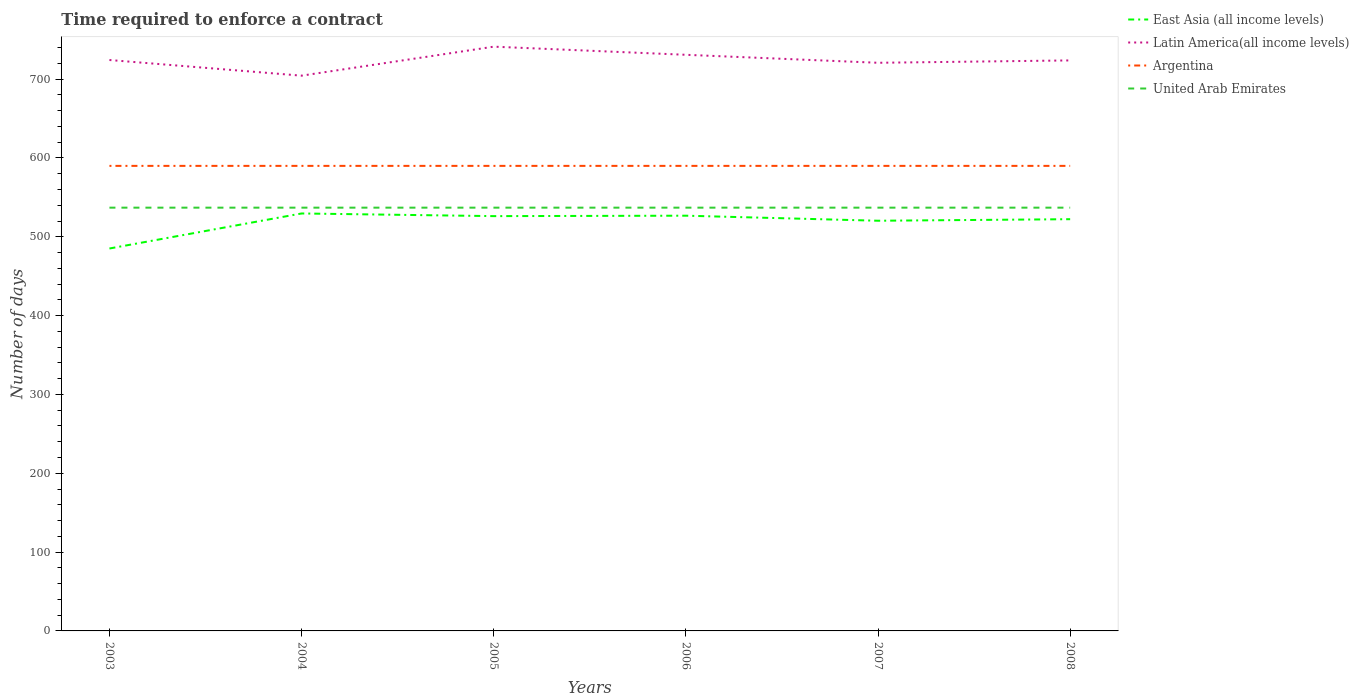Does the line corresponding to Argentina intersect with the line corresponding to East Asia (all income levels)?
Provide a short and direct response. No. Is the number of lines equal to the number of legend labels?
Make the answer very short. Yes. Across all years, what is the maximum number of days required to enforce a contract in Latin America(all income levels)?
Ensure brevity in your answer.  704.45. What is the total number of days required to enforce a contract in United Arab Emirates in the graph?
Give a very brief answer. 0. What is the difference between the highest and the second highest number of days required to enforce a contract in Latin America(all income levels)?
Make the answer very short. 36.79. What is the difference between the highest and the lowest number of days required to enforce a contract in United Arab Emirates?
Your response must be concise. 0. Is the number of days required to enforce a contract in East Asia (all income levels) strictly greater than the number of days required to enforce a contract in Argentina over the years?
Provide a succinct answer. Yes. What is the difference between two consecutive major ticks on the Y-axis?
Your answer should be very brief. 100. Are the values on the major ticks of Y-axis written in scientific E-notation?
Offer a terse response. No. Where does the legend appear in the graph?
Your answer should be compact. Top right. How are the legend labels stacked?
Provide a short and direct response. Vertical. What is the title of the graph?
Keep it short and to the point. Time required to enforce a contract. Does "Denmark" appear as one of the legend labels in the graph?
Offer a very short reply. No. What is the label or title of the X-axis?
Give a very brief answer. Years. What is the label or title of the Y-axis?
Offer a very short reply. Number of days. What is the Number of days of East Asia (all income levels) in 2003?
Give a very brief answer. 485.17. What is the Number of days in Latin America(all income levels) in 2003?
Ensure brevity in your answer.  724.32. What is the Number of days of Argentina in 2003?
Your answer should be very brief. 590. What is the Number of days of United Arab Emirates in 2003?
Offer a very short reply. 537. What is the Number of days in East Asia (all income levels) in 2004?
Ensure brevity in your answer.  529.62. What is the Number of days in Latin America(all income levels) in 2004?
Your answer should be compact. 704.45. What is the Number of days in Argentina in 2004?
Your answer should be very brief. 590. What is the Number of days in United Arab Emirates in 2004?
Provide a succinct answer. 537. What is the Number of days of East Asia (all income levels) in 2005?
Give a very brief answer. 526.25. What is the Number of days of Latin America(all income levels) in 2005?
Your answer should be very brief. 741.24. What is the Number of days in Argentina in 2005?
Make the answer very short. 590. What is the Number of days of United Arab Emirates in 2005?
Give a very brief answer. 537. What is the Number of days of East Asia (all income levels) in 2006?
Ensure brevity in your answer.  526.8. What is the Number of days of Latin America(all income levels) in 2006?
Your response must be concise. 730.93. What is the Number of days of Argentina in 2006?
Offer a very short reply. 590. What is the Number of days of United Arab Emirates in 2006?
Your response must be concise. 537. What is the Number of days of East Asia (all income levels) in 2007?
Your answer should be compact. 520.4. What is the Number of days in Latin America(all income levels) in 2007?
Give a very brief answer. 720.8. What is the Number of days in Argentina in 2007?
Keep it short and to the point. 590. What is the Number of days of United Arab Emirates in 2007?
Your response must be concise. 537. What is the Number of days of East Asia (all income levels) in 2008?
Keep it short and to the point. 522.36. What is the Number of days in Latin America(all income levels) in 2008?
Ensure brevity in your answer.  723.8. What is the Number of days of Argentina in 2008?
Make the answer very short. 590. What is the Number of days in United Arab Emirates in 2008?
Your answer should be compact. 537. Across all years, what is the maximum Number of days of East Asia (all income levels)?
Provide a short and direct response. 529.62. Across all years, what is the maximum Number of days of Latin America(all income levels)?
Make the answer very short. 741.24. Across all years, what is the maximum Number of days in Argentina?
Offer a terse response. 590. Across all years, what is the maximum Number of days of United Arab Emirates?
Offer a very short reply. 537. Across all years, what is the minimum Number of days of East Asia (all income levels)?
Your answer should be very brief. 485.17. Across all years, what is the minimum Number of days in Latin America(all income levels)?
Provide a succinct answer. 704.45. Across all years, what is the minimum Number of days of Argentina?
Make the answer very short. 590. Across all years, what is the minimum Number of days in United Arab Emirates?
Your response must be concise. 537. What is the total Number of days in East Asia (all income levels) in the graph?
Give a very brief answer. 3110.61. What is the total Number of days of Latin America(all income levels) in the graph?
Provide a short and direct response. 4345.54. What is the total Number of days of Argentina in the graph?
Offer a very short reply. 3540. What is the total Number of days in United Arab Emirates in the graph?
Your answer should be very brief. 3222. What is the difference between the Number of days of East Asia (all income levels) in 2003 and that in 2004?
Offer a terse response. -44.45. What is the difference between the Number of days of Latin America(all income levels) in 2003 and that in 2004?
Your answer should be compact. 19.87. What is the difference between the Number of days of Argentina in 2003 and that in 2004?
Your answer should be very brief. 0. What is the difference between the Number of days of East Asia (all income levels) in 2003 and that in 2005?
Your response must be concise. -41.08. What is the difference between the Number of days of Latin America(all income levels) in 2003 and that in 2005?
Offer a terse response. -16.93. What is the difference between the Number of days in Argentina in 2003 and that in 2005?
Offer a very short reply. 0. What is the difference between the Number of days in United Arab Emirates in 2003 and that in 2005?
Make the answer very short. 0. What is the difference between the Number of days in East Asia (all income levels) in 2003 and that in 2006?
Provide a short and direct response. -41.63. What is the difference between the Number of days of Latin America(all income levels) in 2003 and that in 2006?
Keep it short and to the point. -6.62. What is the difference between the Number of days in East Asia (all income levels) in 2003 and that in 2007?
Your answer should be very brief. -35.23. What is the difference between the Number of days of Latin America(all income levels) in 2003 and that in 2007?
Your answer should be very brief. 3.52. What is the difference between the Number of days in East Asia (all income levels) in 2003 and that in 2008?
Keep it short and to the point. -37.19. What is the difference between the Number of days in Latin America(all income levels) in 2003 and that in 2008?
Your answer should be very brief. 0.52. What is the difference between the Number of days of United Arab Emirates in 2003 and that in 2008?
Keep it short and to the point. 0. What is the difference between the Number of days of East Asia (all income levels) in 2004 and that in 2005?
Provide a succinct answer. 3.38. What is the difference between the Number of days in Latin America(all income levels) in 2004 and that in 2005?
Offer a terse response. -36.79. What is the difference between the Number of days of United Arab Emirates in 2004 and that in 2005?
Ensure brevity in your answer.  0. What is the difference between the Number of days of East Asia (all income levels) in 2004 and that in 2006?
Provide a succinct answer. 2.83. What is the difference between the Number of days in Latin America(all income levels) in 2004 and that in 2006?
Offer a terse response. -26.48. What is the difference between the Number of days in Argentina in 2004 and that in 2006?
Give a very brief answer. 0. What is the difference between the Number of days of United Arab Emirates in 2004 and that in 2006?
Keep it short and to the point. 0. What is the difference between the Number of days in East Asia (all income levels) in 2004 and that in 2007?
Provide a succinct answer. 9.22. What is the difference between the Number of days of Latin America(all income levels) in 2004 and that in 2007?
Offer a very short reply. -16.35. What is the difference between the Number of days of Argentina in 2004 and that in 2007?
Offer a very short reply. 0. What is the difference between the Number of days in United Arab Emirates in 2004 and that in 2007?
Your response must be concise. 0. What is the difference between the Number of days in East Asia (all income levels) in 2004 and that in 2008?
Give a very brief answer. 7.26. What is the difference between the Number of days of Latin America(all income levels) in 2004 and that in 2008?
Offer a terse response. -19.35. What is the difference between the Number of days in Argentina in 2004 and that in 2008?
Offer a very short reply. 0. What is the difference between the Number of days of East Asia (all income levels) in 2005 and that in 2006?
Your response must be concise. -0.55. What is the difference between the Number of days in Latin America(all income levels) in 2005 and that in 2006?
Your response must be concise. 10.31. What is the difference between the Number of days in United Arab Emirates in 2005 and that in 2006?
Provide a succinct answer. 0. What is the difference between the Number of days in East Asia (all income levels) in 2005 and that in 2007?
Offer a very short reply. 5.85. What is the difference between the Number of days of Latin America(all income levels) in 2005 and that in 2007?
Your response must be concise. 20.44. What is the difference between the Number of days in Argentina in 2005 and that in 2007?
Provide a succinct answer. 0. What is the difference between the Number of days of East Asia (all income levels) in 2005 and that in 2008?
Make the answer very short. 3.89. What is the difference between the Number of days of Latin America(all income levels) in 2005 and that in 2008?
Offer a very short reply. 17.44. What is the difference between the Number of days in Argentina in 2005 and that in 2008?
Make the answer very short. 0. What is the difference between the Number of days in Latin America(all income levels) in 2006 and that in 2007?
Provide a succinct answer. 10.13. What is the difference between the Number of days in Argentina in 2006 and that in 2007?
Your answer should be very brief. 0. What is the difference between the Number of days in United Arab Emirates in 2006 and that in 2007?
Make the answer very short. 0. What is the difference between the Number of days of East Asia (all income levels) in 2006 and that in 2008?
Offer a terse response. 4.44. What is the difference between the Number of days in Latin America(all income levels) in 2006 and that in 2008?
Provide a short and direct response. 7.13. What is the difference between the Number of days in United Arab Emirates in 2006 and that in 2008?
Offer a terse response. 0. What is the difference between the Number of days of East Asia (all income levels) in 2007 and that in 2008?
Keep it short and to the point. -1.96. What is the difference between the Number of days in Latin America(all income levels) in 2007 and that in 2008?
Offer a terse response. -3. What is the difference between the Number of days in United Arab Emirates in 2007 and that in 2008?
Provide a succinct answer. 0. What is the difference between the Number of days in East Asia (all income levels) in 2003 and the Number of days in Latin America(all income levels) in 2004?
Offer a very short reply. -219.28. What is the difference between the Number of days of East Asia (all income levels) in 2003 and the Number of days of Argentina in 2004?
Make the answer very short. -104.83. What is the difference between the Number of days of East Asia (all income levels) in 2003 and the Number of days of United Arab Emirates in 2004?
Your answer should be compact. -51.83. What is the difference between the Number of days of Latin America(all income levels) in 2003 and the Number of days of Argentina in 2004?
Provide a succinct answer. 134.32. What is the difference between the Number of days in Latin America(all income levels) in 2003 and the Number of days in United Arab Emirates in 2004?
Ensure brevity in your answer.  187.32. What is the difference between the Number of days in East Asia (all income levels) in 2003 and the Number of days in Latin America(all income levels) in 2005?
Ensure brevity in your answer.  -256.07. What is the difference between the Number of days of East Asia (all income levels) in 2003 and the Number of days of Argentina in 2005?
Your answer should be compact. -104.83. What is the difference between the Number of days of East Asia (all income levels) in 2003 and the Number of days of United Arab Emirates in 2005?
Your response must be concise. -51.83. What is the difference between the Number of days in Latin America(all income levels) in 2003 and the Number of days in Argentina in 2005?
Make the answer very short. 134.32. What is the difference between the Number of days in Latin America(all income levels) in 2003 and the Number of days in United Arab Emirates in 2005?
Provide a succinct answer. 187.32. What is the difference between the Number of days of East Asia (all income levels) in 2003 and the Number of days of Latin America(all income levels) in 2006?
Your answer should be very brief. -245.76. What is the difference between the Number of days in East Asia (all income levels) in 2003 and the Number of days in Argentina in 2006?
Provide a short and direct response. -104.83. What is the difference between the Number of days in East Asia (all income levels) in 2003 and the Number of days in United Arab Emirates in 2006?
Give a very brief answer. -51.83. What is the difference between the Number of days in Latin America(all income levels) in 2003 and the Number of days in Argentina in 2006?
Provide a succinct answer. 134.32. What is the difference between the Number of days in Latin America(all income levels) in 2003 and the Number of days in United Arab Emirates in 2006?
Provide a short and direct response. 187.32. What is the difference between the Number of days of East Asia (all income levels) in 2003 and the Number of days of Latin America(all income levels) in 2007?
Your answer should be compact. -235.63. What is the difference between the Number of days of East Asia (all income levels) in 2003 and the Number of days of Argentina in 2007?
Make the answer very short. -104.83. What is the difference between the Number of days in East Asia (all income levels) in 2003 and the Number of days in United Arab Emirates in 2007?
Provide a short and direct response. -51.83. What is the difference between the Number of days in Latin America(all income levels) in 2003 and the Number of days in Argentina in 2007?
Offer a very short reply. 134.32. What is the difference between the Number of days in Latin America(all income levels) in 2003 and the Number of days in United Arab Emirates in 2007?
Your response must be concise. 187.32. What is the difference between the Number of days of East Asia (all income levels) in 2003 and the Number of days of Latin America(all income levels) in 2008?
Make the answer very short. -238.63. What is the difference between the Number of days in East Asia (all income levels) in 2003 and the Number of days in Argentina in 2008?
Your answer should be very brief. -104.83. What is the difference between the Number of days of East Asia (all income levels) in 2003 and the Number of days of United Arab Emirates in 2008?
Make the answer very short. -51.83. What is the difference between the Number of days in Latin America(all income levels) in 2003 and the Number of days in Argentina in 2008?
Make the answer very short. 134.32. What is the difference between the Number of days in Latin America(all income levels) in 2003 and the Number of days in United Arab Emirates in 2008?
Provide a succinct answer. 187.32. What is the difference between the Number of days of Argentina in 2003 and the Number of days of United Arab Emirates in 2008?
Provide a succinct answer. 53. What is the difference between the Number of days of East Asia (all income levels) in 2004 and the Number of days of Latin America(all income levels) in 2005?
Keep it short and to the point. -211.62. What is the difference between the Number of days of East Asia (all income levels) in 2004 and the Number of days of Argentina in 2005?
Your answer should be compact. -60.38. What is the difference between the Number of days of East Asia (all income levels) in 2004 and the Number of days of United Arab Emirates in 2005?
Your answer should be compact. -7.38. What is the difference between the Number of days in Latin America(all income levels) in 2004 and the Number of days in Argentina in 2005?
Give a very brief answer. 114.45. What is the difference between the Number of days of Latin America(all income levels) in 2004 and the Number of days of United Arab Emirates in 2005?
Give a very brief answer. 167.45. What is the difference between the Number of days in Argentina in 2004 and the Number of days in United Arab Emirates in 2005?
Provide a succinct answer. 53. What is the difference between the Number of days in East Asia (all income levels) in 2004 and the Number of days in Latin America(all income levels) in 2006?
Ensure brevity in your answer.  -201.31. What is the difference between the Number of days of East Asia (all income levels) in 2004 and the Number of days of Argentina in 2006?
Give a very brief answer. -60.38. What is the difference between the Number of days in East Asia (all income levels) in 2004 and the Number of days in United Arab Emirates in 2006?
Your response must be concise. -7.38. What is the difference between the Number of days in Latin America(all income levels) in 2004 and the Number of days in Argentina in 2006?
Offer a very short reply. 114.45. What is the difference between the Number of days in Latin America(all income levels) in 2004 and the Number of days in United Arab Emirates in 2006?
Provide a succinct answer. 167.45. What is the difference between the Number of days of Argentina in 2004 and the Number of days of United Arab Emirates in 2006?
Your answer should be very brief. 53. What is the difference between the Number of days of East Asia (all income levels) in 2004 and the Number of days of Latin America(all income levels) in 2007?
Give a very brief answer. -191.18. What is the difference between the Number of days of East Asia (all income levels) in 2004 and the Number of days of Argentina in 2007?
Offer a very short reply. -60.38. What is the difference between the Number of days in East Asia (all income levels) in 2004 and the Number of days in United Arab Emirates in 2007?
Your answer should be compact. -7.38. What is the difference between the Number of days of Latin America(all income levels) in 2004 and the Number of days of Argentina in 2007?
Offer a terse response. 114.45. What is the difference between the Number of days of Latin America(all income levels) in 2004 and the Number of days of United Arab Emirates in 2007?
Offer a very short reply. 167.45. What is the difference between the Number of days in East Asia (all income levels) in 2004 and the Number of days in Latin America(all income levels) in 2008?
Your answer should be compact. -194.18. What is the difference between the Number of days of East Asia (all income levels) in 2004 and the Number of days of Argentina in 2008?
Your response must be concise. -60.38. What is the difference between the Number of days of East Asia (all income levels) in 2004 and the Number of days of United Arab Emirates in 2008?
Offer a terse response. -7.38. What is the difference between the Number of days of Latin America(all income levels) in 2004 and the Number of days of Argentina in 2008?
Your answer should be compact. 114.45. What is the difference between the Number of days of Latin America(all income levels) in 2004 and the Number of days of United Arab Emirates in 2008?
Your answer should be compact. 167.45. What is the difference between the Number of days in Argentina in 2004 and the Number of days in United Arab Emirates in 2008?
Offer a terse response. 53. What is the difference between the Number of days of East Asia (all income levels) in 2005 and the Number of days of Latin America(all income levels) in 2006?
Provide a short and direct response. -204.68. What is the difference between the Number of days of East Asia (all income levels) in 2005 and the Number of days of Argentina in 2006?
Your answer should be very brief. -63.75. What is the difference between the Number of days in East Asia (all income levels) in 2005 and the Number of days in United Arab Emirates in 2006?
Keep it short and to the point. -10.75. What is the difference between the Number of days of Latin America(all income levels) in 2005 and the Number of days of Argentina in 2006?
Make the answer very short. 151.24. What is the difference between the Number of days of Latin America(all income levels) in 2005 and the Number of days of United Arab Emirates in 2006?
Your answer should be very brief. 204.24. What is the difference between the Number of days of Argentina in 2005 and the Number of days of United Arab Emirates in 2006?
Provide a succinct answer. 53. What is the difference between the Number of days of East Asia (all income levels) in 2005 and the Number of days of Latin America(all income levels) in 2007?
Make the answer very short. -194.55. What is the difference between the Number of days in East Asia (all income levels) in 2005 and the Number of days in Argentina in 2007?
Your answer should be very brief. -63.75. What is the difference between the Number of days of East Asia (all income levels) in 2005 and the Number of days of United Arab Emirates in 2007?
Provide a succinct answer. -10.75. What is the difference between the Number of days of Latin America(all income levels) in 2005 and the Number of days of Argentina in 2007?
Provide a succinct answer. 151.24. What is the difference between the Number of days of Latin America(all income levels) in 2005 and the Number of days of United Arab Emirates in 2007?
Your answer should be very brief. 204.24. What is the difference between the Number of days of East Asia (all income levels) in 2005 and the Number of days of Latin America(all income levels) in 2008?
Keep it short and to the point. -197.55. What is the difference between the Number of days of East Asia (all income levels) in 2005 and the Number of days of Argentina in 2008?
Offer a very short reply. -63.75. What is the difference between the Number of days in East Asia (all income levels) in 2005 and the Number of days in United Arab Emirates in 2008?
Give a very brief answer. -10.75. What is the difference between the Number of days in Latin America(all income levels) in 2005 and the Number of days in Argentina in 2008?
Your answer should be very brief. 151.24. What is the difference between the Number of days in Latin America(all income levels) in 2005 and the Number of days in United Arab Emirates in 2008?
Offer a terse response. 204.24. What is the difference between the Number of days of East Asia (all income levels) in 2006 and the Number of days of Latin America(all income levels) in 2007?
Ensure brevity in your answer.  -194. What is the difference between the Number of days of East Asia (all income levels) in 2006 and the Number of days of Argentina in 2007?
Provide a short and direct response. -63.2. What is the difference between the Number of days in East Asia (all income levels) in 2006 and the Number of days in United Arab Emirates in 2007?
Ensure brevity in your answer.  -10.2. What is the difference between the Number of days of Latin America(all income levels) in 2006 and the Number of days of Argentina in 2007?
Make the answer very short. 140.93. What is the difference between the Number of days of Latin America(all income levels) in 2006 and the Number of days of United Arab Emirates in 2007?
Provide a succinct answer. 193.93. What is the difference between the Number of days in Argentina in 2006 and the Number of days in United Arab Emirates in 2007?
Ensure brevity in your answer.  53. What is the difference between the Number of days in East Asia (all income levels) in 2006 and the Number of days in Latin America(all income levels) in 2008?
Your answer should be very brief. -197. What is the difference between the Number of days of East Asia (all income levels) in 2006 and the Number of days of Argentina in 2008?
Give a very brief answer. -63.2. What is the difference between the Number of days in Latin America(all income levels) in 2006 and the Number of days in Argentina in 2008?
Your answer should be very brief. 140.93. What is the difference between the Number of days of Latin America(all income levels) in 2006 and the Number of days of United Arab Emirates in 2008?
Make the answer very short. 193.93. What is the difference between the Number of days in Argentina in 2006 and the Number of days in United Arab Emirates in 2008?
Provide a succinct answer. 53. What is the difference between the Number of days of East Asia (all income levels) in 2007 and the Number of days of Latin America(all income levels) in 2008?
Keep it short and to the point. -203.4. What is the difference between the Number of days of East Asia (all income levels) in 2007 and the Number of days of Argentina in 2008?
Your answer should be very brief. -69.6. What is the difference between the Number of days of East Asia (all income levels) in 2007 and the Number of days of United Arab Emirates in 2008?
Give a very brief answer. -16.6. What is the difference between the Number of days of Latin America(all income levels) in 2007 and the Number of days of Argentina in 2008?
Give a very brief answer. 130.8. What is the difference between the Number of days of Latin America(all income levels) in 2007 and the Number of days of United Arab Emirates in 2008?
Ensure brevity in your answer.  183.8. What is the difference between the Number of days of Argentina in 2007 and the Number of days of United Arab Emirates in 2008?
Make the answer very short. 53. What is the average Number of days in East Asia (all income levels) per year?
Give a very brief answer. 518.43. What is the average Number of days of Latin America(all income levels) per year?
Your answer should be very brief. 724.26. What is the average Number of days in Argentina per year?
Provide a short and direct response. 590. What is the average Number of days of United Arab Emirates per year?
Keep it short and to the point. 537. In the year 2003, what is the difference between the Number of days in East Asia (all income levels) and Number of days in Latin America(all income levels)?
Give a very brief answer. -239.14. In the year 2003, what is the difference between the Number of days in East Asia (all income levels) and Number of days in Argentina?
Ensure brevity in your answer.  -104.83. In the year 2003, what is the difference between the Number of days in East Asia (all income levels) and Number of days in United Arab Emirates?
Your response must be concise. -51.83. In the year 2003, what is the difference between the Number of days of Latin America(all income levels) and Number of days of Argentina?
Provide a short and direct response. 134.32. In the year 2003, what is the difference between the Number of days in Latin America(all income levels) and Number of days in United Arab Emirates?
Provide a short and direct response. 187.32. In the year 2004, what is the difference between the Number of days of East Asia (all income levels) and Number of days of Latin America(all income levels)?
Your answer should be very brief. -174.82. In the year 2004, what is the difference between the Number of days of East Asia (all income levels) and Number of days of Argentina?
Provide a succinct answer. -60.38. In the year 2004, what is the difference between the Number of days in East Asia (all income levels) and Number of days in United Arab Emirates?
Keep it short and to the point. -7.38. In the year 2004, what is the difference between the Number of days of Latin America(all income levels) and Number of days of Argentina?
Offer a terse response. 114.45. In the year 2004, what is the difference between the Number of days of Latin America(all income levels) and Number of days of United Arab Emirates?
Give a very brief answer. 167.45. In the year 2005, what is the difference between the Number of days of East Asia (all income levels) and Number of days of Latin America(all income levels)?
Offer a very short reply. -214.99. In the year 2005, what is the difference between the Number of days of East Asia (all income levels) and Number of days of Argentina?
Ensure brevity in your answer.  -63.75. In the year 2005, what is the difference between the Number of days in East Asia (all income levels) and Number of days in United Arab Emirates?
Offer a terse response. -10.75. In the year 2005, what is the difference between the Number of days in Latin America(all income levels) and Number of days in Argentina?
Your answer should be compact. 151.24. In the year 2005, what is the difference between the Number of days of Latin America(all income levels) and Number of days of United Arab Emirates?
Your response must be concise. 204.24. In the year 2006, what is the difference between the Number of days in East Asia (all income levels) and Number of days in Latin America(all income levels)?
Offer a very short reply. -204.13. In the year 2006, what is the difference between the Number of days in East Asia (all income levels) and Number of days in Argentina?
Provide a short and direct response. -63.2. In the year 2006, what is the difference between the Number of days of East Asia (all income levels) and Number of days of United Arab Emirates?
Your response must be concise. -10.2. In the year 2006, what is the difference between the Number of days in Latin America(all income levels) and Number of days in Argentina?
Provide a succinct answer. 140.93. In the year 2006, what is the difference between the Number of days of Latin America(all income levels) and Number of days of United Arab Emirates?
Provide a short and direct response. 193.93. In the year 2006, what is the difference between the Number of days of Argentina and Number of days of United Arab Emirates?
Ensure brevity in your answer.  53. In the year 2007, what is the difference between the Number of days of East Asia (all income levels) and Number of days of Latin America(all income levels)?
Your response must be concise. -200.4. In the year 2007, what is the difference between the Number of days of East Asia (all income levels) and Number of days of Argentina?
Keep it short and to the point. -69.6. In the year 2007, what is the difference between the Number of days of East Asia (all income levels) and Number of days of United Arab Emirates?
Give a very brief answer. -16.6. In the year 2007, what is the difference between the Number of days in Latin America(all income levels) and Number of days in Argentina?
Your answer should be compact. 130.8. In the year 2007, what is the difference between the Number of days of Latin America(all income levels) and Number of days of United Arab Emirates?
Your response must be concise. 183.8. In the year 2007, what is the difference between the Number of days in Argentina and Number of days in United Arab Emirates?
Your response must be concise. 53. In the year 2008, what is the difference between the Number of days in East Asia (all income levels) and Number of days in Latin America(all income levels)?
Ensure brevity in your answer.  -201.44. In the year 2008, what is the difference between the Number of days of East Asia (all income levels) and Number of days of Argentina?
Your answer should be very brief. -67.64. In the year 2008, what is the difference between the Number of days in East Asia (all income levels) and Number of days in United Arab Emirates?
Your answer should be compact. -14.64. In the year 2008, what is the difference between the Number of days of Latin America(all income levels) and Number of days of Argentina?
Give a very brief answer. 133.8. In the year 2008, what is the difference between the Number of days of Latin America(all income levels) and Number of days of United Arab Emirates?
Provide a succinct answer. 186.8. In the year 2008, what is the difference between the Number of days of Argentina and Number of days of United Arab Emirates?
Your response must be concise. 53. What is the ratio of the Number of days in East Asia (all income levels) in 2003 to that in 2004?
Your response must be concise. 0.92. What is the ratio of the Number of days of Latin America(all income levels) in 2003 to that in 2004?
Keep it short and to the point. 1.03. What is the ratio of the Number of days of East Asia (all income levels) in 2003 to that in 2005?
Give a very brief answer. 0.92. What is the ratio of the Number of days of Latin America(all income levels) in 2003 to that in 2005?
Offer a very short reply. 0.98. What is the ratio of the Number of days of United Arab Emirates in 2003 to that in 2005?
Offer a very short reply. 1. What is the ratio of the Number of days of East Asia (all income levels) in 2003 to that in 2006?
Offer a very short reply. 0.92. What is the ratio of the Number of days of Latin America(all income levels) in 2003 to that in 2006?
Your answer should be very brief. 0.99. What is the ratio of the Number of days of Argentina in 2003 to that in 2006?
Ensure brevity in your answer.  1. What is the ratio of the Number of days of United Arab Emirates in 2003 to that in 2006?
Make the answer very short. 1. What is the ratio of the Number of days in East Asia (all income levels) in 2003 to that in 2007?
Your answer should be very brief. 0.93. What is the ratio of the Number of days in Latin America(all income levels) in 2003 to that in 2007?
Provide a succinct answer. 1. What is the ratio of the Number of days of United Arab Emirates in 2003 to that in 2007?
Ensure brevity in your answer.  1. What is the ratio of the Number of days of East Asia (all income levels) in 2003 to that in 2008?
Your answer should be compact. 0.93. What is the ratio of the Number of days in Latin America(all income levels) in 2003 to that in 2008?
Ensure brevity in your answer.  1. What is the ratio of the Number of days of United Arab Emirates in 2003 to that in 2008?
Your response must be concise. 1. What is the ratio of the Number of days in East Asia (all income levels) in 2004 to that in 2005?
Offer a terse response. 1.01. What is the ratio of the Number of days of Latin America(all income levels) in 2004 to that in 2005?
Make the answer very short. 0.95. What is the ratio of the Number of days of East Asia (all income levels) in 2004 to that in 2006?
Make the answer very short. 1.01. What is the ratio of the Number of days of Latin America(all income levels) in 2004 to that in 2006?
Keep it short and to the point. 0.96. What is the ratio of the Number of days in Argentina in 2004 to that in 2006?
Offer a terse response. 1. What is the ratio of the Number of days of United Arab Emirates in 2004 to that in 2006?
Your answer should be very brief. 1. What is the ratio of the Number of days in East Asia (all income levels) in 2004 to that in 2007?
Your answer should be very brief. 1.02. What is the ratio of the Number of days of Latin America(all income levels) in 2004 to that in 2007?
Make the answer very short. 0.98. What is the ratio of the Number of days in United Arab Emirates in 2004 to that in 2007?
Provide a short and direct response. 1. What is the ratio of the Number of days of East Asia (all income levels) in 2004 to that in 2008?
Your answer should be compact. 1.01. What is the ratio of the Number of days of Latin America(all income levels) in 2004 to that in 2008?
Offer a terse response. 0.97. What is the ratio of the Number of days in United Arab Emirates in 2004 to that in 2008?
Your answer should be compact. 1. What is the ratio of the Number of days of Latin America(all income levels) in 2005 to that in 2006?
Provide a short and direct response. 1.01. What is the ratio of the Number of days in East Asia (all income levels) in 2005 to that in 2007?
Offer a terse response. 1.01. What is the ratio of the Number of days in Latin America(all income levels) in 2005 to that in 2007?
Offer a very short reply. 1.03. What is the ratio of the Number of days in East Asia (all income levels) in 2005 to that in 2008?
Your answer should be compact. 1.01. What is the ratio of the Number of days of Latin America(all income levels) in 2005 to that in 2008?
Your response must be concise. 1.02. What is the ratio of the Number of days of Argentina in 2005 to that in 2008?
Keep it short and to the point. 1. What is the ratio of the Number of days in United Arab Emirates in 2005 to that in 2008?
Offer a very short reply. 1. What is the ratio of the Number of days of East Asia (all income levels) in 2006 to that in 2007?
Make the answer very short. 1.01. What is the ratio of the Number of days in Latin America(all income levels) in 2006 to that in 2007?
Provide a succinct answer. 1.01. What is the ratio of the Number of days in Argentina in 2006 to that in 2007?
Offer a terse response. 1. What is the ratio of the Number of days in East Asia (all income levels) in 2006 to that in 2008?
Offer a very short reply. 1.01. What is the ratio of the Number of days of Latin America(all income levels) in 2006 to that in 2008?
Keep it short and to the point. 1.01. What is the ratio of the Number of days in United Arab Emirates in 2006 to that in 2008?
Your answer should be compact. 1. What is the ratio of the Number of days in Latin America(all income levels) in 2007 to that in 2008?
Offer a very short reply. 1. What is the ratio of the Number of days of Argentina in 2007 to that in 2008?
Your response must be concise. 1. What is the difference between the highest and the second highest Number of days in East Asia (all income levels)?
Provide a succinct answer. 2.83. What is the difference between the highest and the second highest Number of days of Latin America(all income levels)?
Your response must be concise. 10.31. What is the difference between the highest and the lowest Number of days of East Asia (all income levels)?
Your response must be concise. 44.45. What is the difference between the highest and the lowest Number of days of Latin America(all income levels)?
Offer a terse response. 36.79. What is the difference between the highest and the lowest Number of days of Argentina?
Offer a very short reply. 0. What is the difference between the highest and the lowest Number of days of United Arab Emirates?
Make the answer very short. 0. 